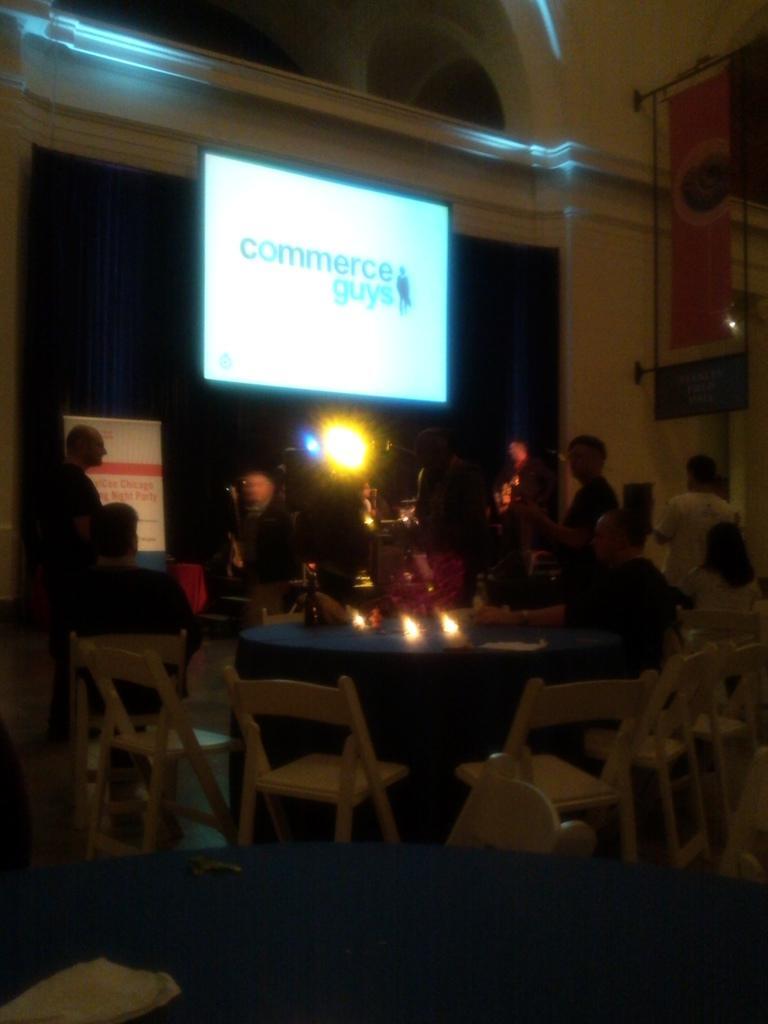Describe this image in one or two sentences. The picture seems to be clicked in a restaurant and there is a meeting going on. there are dining tables and chairs and people in front stood. 